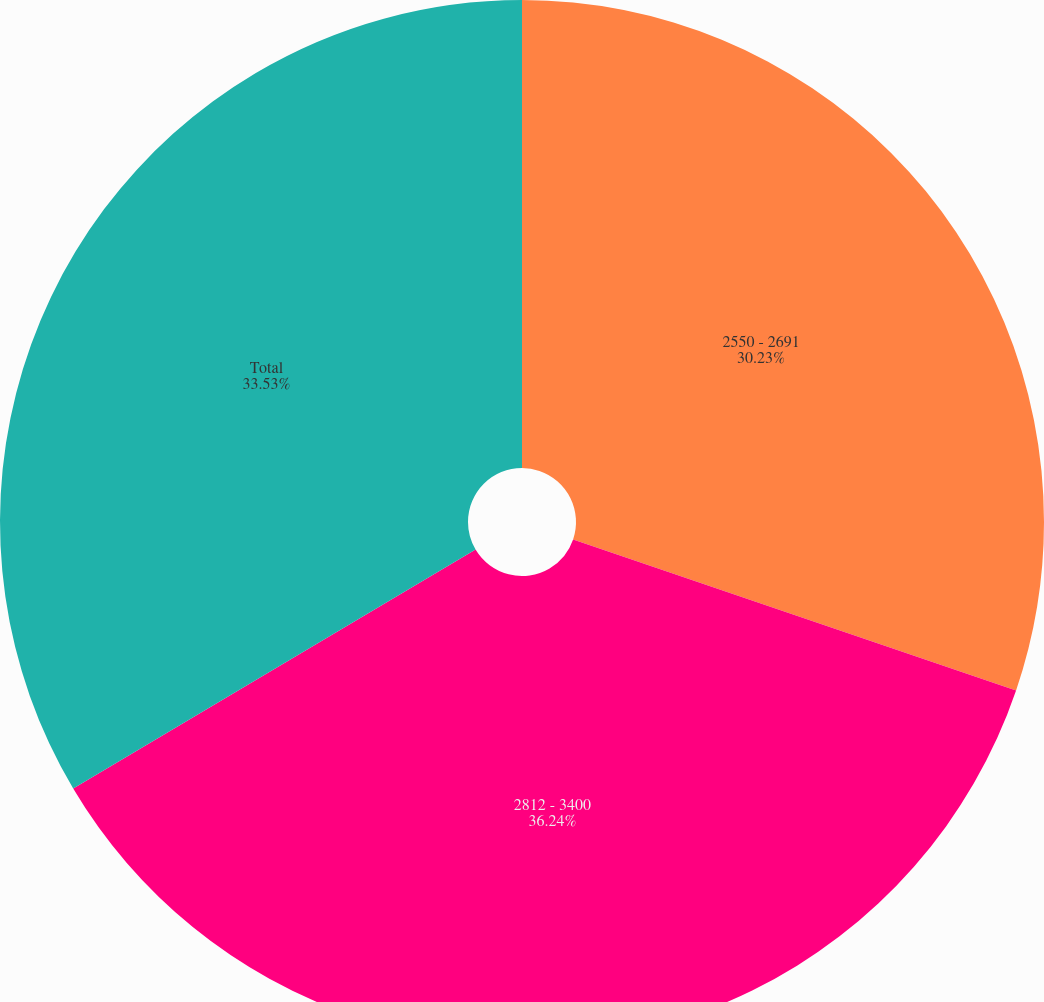Convert chart to OTSL. <chart><loc_0><loc_0><loc_500><loc_500><pie_chart><fcel>2550 - 2691<fcel>2812 - 3400<fcel>Total<nl><fcel>30.23%<fcel>36.24%<fcel>33.53%<nl></chart> 